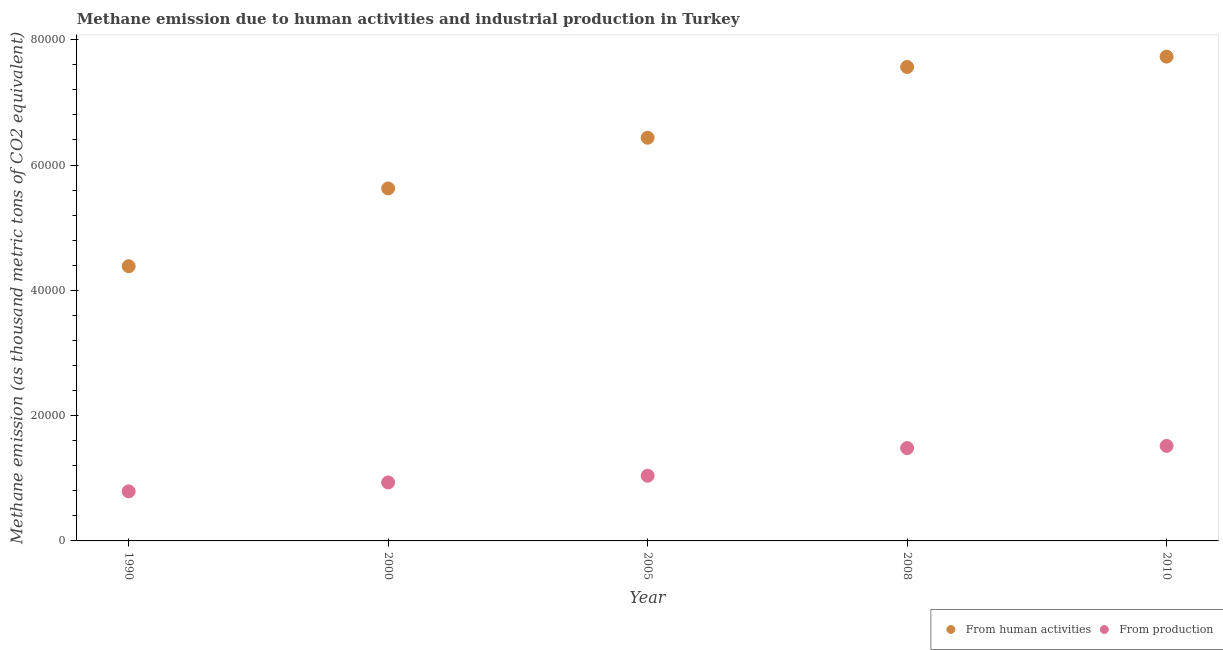How many different coloured dotlines are there?
Provide a short and direct response. 2. What is the amount of emissions generated from industries in 2000?
Give a very brief answer. 9337. Across all years, what is the maximum amount of emissions generated from industries?
Offer a terse response. 1.52e+04. Across all years, what is the minimum amount of emissions generated from industries?
Ensure brevity in your answer.  7912.1. In which year was the amount of emissions generated from industries maximum?
Your response must be concise. 2010. In which year was the amount of emissions generated from industries minimum?
Provide a short and direct response. 1990. What is the total amount of emissions from human activities in the graph?
Offer a terse response. 3.17e+05. What is the difference between the amount of emissions from human activities in 2005 and that in 2008?
Offer a very short reply. -1.13e+04. What is the difference between the amount of emissions from human activities in 2010 and the amount of emissions generated from industries in 2005?
Your response must be concise. 6.69e+04. What is the average amount of emissions from human activities per year?
Keep it short and to the point. 6.35e+04. In the year 2008, what is the difference between the amount of emissions generated from industries and amount of emissions from human activities?
Provide a short and direct response. -6.08e+04. What is the ratio of the amount of emissions generated from industries in 1990 to that in 2000?
Give a very brief answer. 0.85. Is the amount of emissions from human activities in 2005 less than that in 2008?
Ensure brevity in your answer.  Yes. What is the difference between the highest and the second highest amount of emissions generated from industries?
Provide a short and direct response. 343.5. What is the difference between the highest and the lowest amount of emissions generated from industries?
Give a very brief answer. 7253.5. Is the sum of the amount of emissions from human activities in 2000 and 2008 greater than the maximum amount of emissions generated from industries across all years?
Your answer should be compact. Yes. Does the amount of emissions generated from industries monotonically increase over the years?
Keep it short and to the point. Yes. Is the amount of emissions from human activities strictly greater than the amount of emissions generated from industries over the years?
Give a very brief answer. Yes. Is the amount of emissions generated from industries strictly less than the amount of emissions from human activities over the years?
Offer a terse response. Yes. How many dotlines are there?
Provide a short and direct response. 2. How many years are there in the graph?
Your response must be concise. 5. Does the graph contain any zero values?
Make the answer very short. No. Where does the legend appear in the graph?
Ensure brevity in your answer.  Bottom right. What is the title of the graph?
Offer a terse response. Methane emission due to human activities and industrial production in Turkey. What is the label or title of the Y-axis?
Your answer should be very brief. Methane emission (as thousand metric tons of CO2 equivalent). What is the Methane emission (as thousand metric tons of CO2 equivalent) in From human activities in 1990?
Make the answer very short. 4.39e+04. What is the Methane emission (as thousand metric tons of CO2 equivalent) of From production in 1990?
Your answer should be compact. 7912.1. What is the Methane emission (as thousand metric tons of CO2 equivalent) in From human activities in 2000?
Your response must be concise. 5.63e+04. What is the Methane emission (as thousand metric tons of CO2 equivalent) of From production in 2000?
Keep it short and to the point. 9337. What is the Methane emission (as thousand metric tons of CO2 equivalent) in From human activities in 2005?
Make the answer very short. 6.44e+04. What is the Methane emission (as thousand metric tons of CO2 equivalent) in From production in 2005?
Keep it short and to the point. 1.04e+04. What is the Methane emission (as thousand metric tons of CO2 equivalent) in From human activities in 2008?
Ensure brevity in your answer.  7.57e+04. What is the Methane emission (as thousand metric tons of CO2 equivalent) of From production in 2008?
Provide a succinct answer. 1.48e+04. What is the Methane emission (as thousand metric tons of CO2 equivalent) in From human activities in 2010?
Your response must be concise. 7.73e+04. What is the Methane emission (as thousand metric tons of CO2 equivalent) in From production in 2010?
Your response must be concise. 1.52e+04. Across all years, what is the maximum Methane emission (as thousand metric tons of CO2 equivalent) in From human activities?
Your answer should be compact. 7.73e+04. Across all years, what is the maximum Methane emission (as thousand metric tons of CO2 equivalent) in From production?
Offer a terse response. 1.52e+04. Across all years, what is the minimum Methane emission (as thousand metric tons of CO2 equivalent) of From human activities?
Your response must be concise. 4.39e+04. Across all years, what is the minimum Methane emission (as thousand metric tons of CO2 equivalent) of From production?
Your response must be concise. 7912.1. What is the total Methane emission (as thousand metric tons of CO2 equivalent) in From human activities in the graph?
Make the answer very short. 3.17e+05. What is the total Methane emission (as thousand metric tons of CO2 equivalent) of From production in the graph?
Keep it short and to the point. 5.76e+04. What is the difference between the Methane emission (as thousand metric tons of CO2 equivalent) of From human activities in 1990 and that in 2000?
Offer a very short reply. -1.24e+04. What is the difference between the Methane emission (as thousand metric tons of CO2 equivalent) in From production in 1990 and that in 2000?
Your response must be concise. -1424.9. What is the difference between the Methane emission (as thousand metric tons of CO2 equivalent) in From human activities in 1990 and that in 2005?
Provide a succinct answer. -2.05e+04. What is the difference between the Methane emission (as thousand metric tons of CO2 equivalent) of From production in 1990 and that in 2005?
Keep it short and to the point. -2494.3. What is the difference between the Methane emission (as thousand metric tons of CO2 equivalent) of From human activities in 1990 and that in 2008?
Provide a short and direct response. -3.18e+04. What is the difference between the Methane emission (as thousand metric tons of CO2 equivalent) in From production in 1990 and that in 2008?
Your answer should be very brief. -6910. What is the difference between the Methane emission (as thousand metric tons of CO2 equivalent) in From human activities in 1990 and that in 2010?
Make the answer very short. -3.35e+04. What is the difference between the Methane emission (as thousand metric tons of CO2 equivalent) in From production in 1990 and that in 2010?
Provide a short and direct response. -7253.5. What is the difference between the Methane emission (as thousand metric tons of CO2 equivalent) in From human activities in 2000 and that in 2005?
Make the answer very short. -8092.9. What is the difference between the Methane emission (as thousand metric tons of CO2 equivalent) of From production in 2000 and that in 2005?
Your answer should be very brief. -1069.4. What is the difference between the Methane emission (as thousand metric tons of CO2 equivalent) in From human activities in 2000 and that in 2008?
Offer a very short reply. -1.94e+04. What is the difference between the Methane emission (as thousand metric tons of CO2 equivalent) in From production in 2000 and that in 2008?
Your response must be concise. -5485.1. What is the difference between the Methane emission (as thousand metric tons of CO2 equivalent) of From human activities in 2000 and that in 2010?
Provide a succinct answer. -2.10e+04. What is the difference between the Methane emission (as thousand metric tons of CO2 equivalent) in From production in 2000 and that in 2010?
Provide a short and direct response. -5828.6. What is the difference between the Methane emission (as thousand metric tons of CO2 equivalent) of From human activities in 2005 and that in 2008?
Offer a very short reply. -1.13e+04. What is the difference between the Methane emission (as thousand metric tons of CO2 equivalent) of From production in 2005 and that in 2008?
Provide a succinct answer. -4415.7. What is the difference between the Methane emission (as thousand metric tons of CO2 equivalent) in From human activities in 2005 and that in 2010?
Provide a succinct answer. -1.30e+04. What is the difference between the Methane emission (as thousand metric tons of CO2 equivalent) of From production in 2005 and that in 2010?
Keep it short and to the point. -4759.2. What is the difference between the Methane emission (as thousand metric tons of CO2 equivalent) in From human activities in 2008 and that in 2010?
Ensure brevity in your answer.  -1655.4. What is the difference between the Methane emission (as thousand metric tons of CO2 equivalent) of From production in 2008 and that in 2010?
Your answer should be compact. -343.5. What is the difference between the Methane emission (as thousand metric tons of CO2 equivalent) in From human activities in 1990 and the Methane emission (as thousand metric tons of CO2 equivalent) in From production in 2000?
Ensure brevity in your answer.  3.45e+04. What is the difference between the Methane emission (as thousand metric tons of CO2 equivalent) of From human activities in 1990 and the Methane emission (as thousand metric tons of CO2 equivalent) of From production in 2005?
Make the answer very short. 3.34e+04. What is the difference between the Methane emission (as thousand metric tons of CO2 equivalent) of From human activities in 1990 and the Methane emission (as thousand metric tons of CO2 equivalent) of From production in 2008?
Ensure brevity in your answer.  2.90e+04. What is the difference between the Methane emission (as thousand metric tons of CO2 equivalent) in From human activities in 1990 and the Methane emission (as thousand metric tons of CO2 equivalent) in From production in 2010?
Offer a very short reply. 2.87e+04. What is the difference between the Methane emission (as thousand metric tons of CO2 equivalent) of From human activities in 2000 and the Methane emission (as thousand metric tons of CO2 equivalent) of From production in 2005?
Your answer should be very brief. 4.59e+04. What is the difference between the Methane emission (as thousand metric tons of CO2 equivalent) of From human activities in 2000 and the Methane emission (as thousand metric tons of CO2 equivalent) of From production in 2008?
Ensure brevity in your answer.  4.14e+04. What is the difference between the Methane emission (as thousand metric tons of CO2 equivalent) in From human activities in 2000 and the Methane emission (as thousand metric tons of CO2 equivalent) in From production in 2010?
Ensure brevity in your answer.  4.11e+04. What is the difference between the Methane emission (as thousand metric tons of CO2 equivalent) in From human activities in 2005 and the Methane emission (as thousand metric tons of CO2 equivalent) in From production in 2008?
Make the answer very short. 4.95e+04. What is the difference between the Methane emission (as thousand metric tons of CO2 equivalent) of From human activities in 2005 and the Methane emission (as thousand metric tons of CO2 equivalent) of From production in 2010?
Your answer should be very brief. 4.92e+04. What is the difference between the Methane emission (as thousand metric tons of CO2 equivalent) in From human activities in 2008 and the Methane emission (as thousand metric tons of CO2 equivalent) in From production in 2010?
Your answer should be compact. 6.05e+04. What is the average Methane emission (as thousand metric tons of CO2 equivalent) of From human activities per year?
Give a very brief answer. 6.35e+04. What is the average Methane emission (as thousand metric tons of CO2 equivalent) in From production per year?
Keep it short and to the point. 1.15e+04. In the year 1990, what is the difference between the Methane emission (as thousand metric tons of CO2 equivalent) in From human activities and Methane emission (as thousand metric tons of CO2 equivalent) in From production?
Ensure brevity in your answer.  3.59e+04. In the year 2000, what is the difference between the Methane emission (as thousand metric tons of CO2 equivalent) in From human activities and Methane emission (as thousand metric tons of CO2 equivalent) in From production?
Your answer should be compact. 4.69e+04. In the year 2005, what is the difference between the Methane emission (as thousand metric tons of CO2 equivalent) of From human activities and Methane emission (as thousand metric tons of CO2 equivalent) of From production?
Ensure brevity in your answer.  5.40e+04. In the year 2008, what is the difference between the Methane emission (as thousand metric tons of CO2 equivalent) of From human activities and Methane emission (as thousand metric tons of CO2 equivalent) of From production?
Your answer should be very brief. 6.08e+04. In the year 2010, what is the difference between the Methane emission (as thousand metric tons of CO2 equivalent) in From human activities and Methane emission (as thousand metric tons of CO2 equivalent) in From production?
Give a very brief answer. 6.21e+04. What is the ratio of the Methane emission (as thousand metric tons of CO2 equivalent) in From human activities in 1990 to that in 2000?
Your answer should be compact. 0.78. What is the ratio of the Methane emission (as thousand metric tons of CO2 equivalent) of From production in 1990 to that in 2000?
Provide a succinct answer. 0.85. What is the ratio of the Methane emission (as thousand metric tons of CO2 equivalent) in From human activities in 1990 to that in 2005?
Ensure brevity in your answer.  0.68. What is the ratio of the Methane emission (as thousand metric tons of CO2 equivalent) of From production in 1990 to that in 2005?
Provide a short and direct response. 0.76. What is the ratio of the Methane emission (as thousand metric tons of CO2 equivalent) in From human activities in 1990 to that in 2008?
Keep it short and to the point. 0.58. What is the ratio of the Methane emission (as thousand metric tons of CO2 equivalent) of From production in 1990 to that in 2008?
Offer a very short reply. 0.53. What is the ratio of the Methane emission (as thousand metric tons of CO2 equivalent) in From human activities in 1990 to that in 2010?
Keep it short and to the point. 0.57. What is the ratio of the Methane emission (as thousand metric tons of CO2 equivalent) in From production in 1990 to that in 2010?
Give a very brief answer. 0.52. What is the ratio of the Methane emission (as thousand metric tons of CO2 equivalent) of From human activities in 2000 to that in 2005?
Provide a short and direct response. 0.87. What is the ratio of the Methane emission (as thousand metric tons of CO2 equivalent) in From production in 2000 to that in 2005?
Provide a short and direct response. 0.9. What is the ratio of the Methane emission (as thousand metric tons of CO2 equivalent) in From human activities in 2000 to that in 2008?
Give a very brief answer. 0.74. What is the ratio of the Methane emission (as thousand metric tons of CO2 equivalent) of From production in 2000 to that in 2008?
Make the answer very short. 0.63. What is the ratio of the Methane emission (as thousand metric tons of CO2 equivalent) of From human activities in 2000 to that in 2010?
Your answer should be very brief. 0.73. What is the ratio of the Methane emission (as thousand metric tons of CO2 equivalent) of From production in 2000 to that in 2010?
Ensure brevity in your answer.  0.62. What is the ratio of the Methane emission (as thousand metric tons of CO2 equivalent) in From human activities in 2005 to that in 2008?
Offer a very short reply. 0.85. What is the ratio of the Methane emission (as thousand metric tons of CO2 equivalent) in From production in 2005 to that in 2008?
Ensure brevity in your answer.  0.7. What is the ratio of the Methane emission (as thousand metric tons of CO2 equivalent) of From human activities in 2005 to that in 2010?
Your response must be concise. 0.83. What is the ratio of the Methane emission (as thousand metric tons of CO2 equivalent) of From production in 2005 to that in 2010?
Your answer should be compact. 0.69. What is the ratio of the Methane emission (as thousand metric tons of CO2 equivalent) in From human activities in 2008 to that in 2010?
Keep it short and to the point. 0.98. What is the ratio of the Methane emission (as thousand metric tons of CO2 equivalent) of From production in 2008 to that in 2010?
Your response must be concise. 0.98. What is the difference between the highest and the second highest Methane emission (as thousand metric tons of CO2 equivalent) of From human activities?
Offer a very short reply. 1655.4. What is the difference between the highest and the second highest Methane emission (as thousand metric tons of CO2 equivalent) in From production?
Make the answer very short. 343.5. What is the difference between the highest and the lowest Methane emission (as thousand metric tons of CO2 equivalent) of From human activities?
Your answer should be compact. 3.35e+04. What is the difference between the highest and the lowest Methane emission (as thousand metric tons of CO2 equivalent) in From production?
Your response must be concise. 7253.5. 